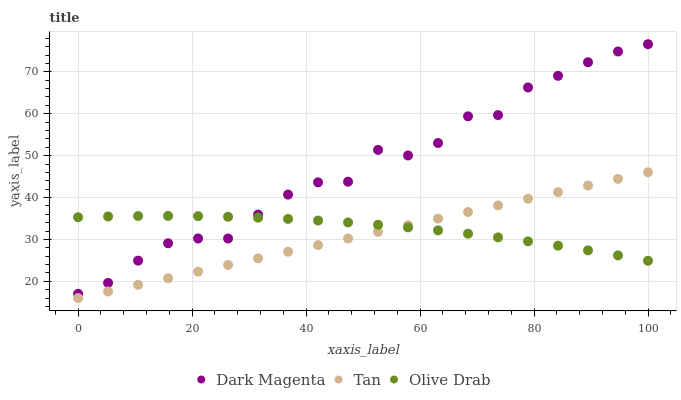Does Tan have the minimum area under the curve?
Answer yes or no. Yes. Does Dark Magenta have the maximum area under the curve?
Answer yes or no. Yes. Does Olive Drab have the minimum area under the curve?
Answer yes or no. No. Does Olive Drab have the maximum area under the curve?
Answer yes or no. No. Is Tan the smoothest?
Answer yes or no. Yes. Is Dark Magenta the roughest?
Answer yes or no. Yes. Is Olive Drab the smoothest?
Answer yes or no. No. Is Olive Drab the roughest?
Answer yes or no. No. Does Tan have the lowest value?
Answer yes or no. Yes. Does Dark Magenta have the lowest value?
Answer yes or no. No. Does Dark Magenta have the highest value?
Answer yes or no. Yes. Does Olive Drab have the highest value?
Answer yes or no. No. Is Tan less than Dark Magenta?
Answer yes or no. Yes. Is Dark Magenta greater than Tan?
Answer yes or no. Yes. Does Tan intersect Olive Drab?
Answer yes or no. Yes. Is Tan less than Olive Drab?
Answer yes or no. No. Is Tan greater than Olive Drab?
Answer yes or no. No. Does Tan intersect Dark Magenta?
Answer yes or no. No. 